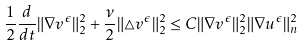Convert formula to latex. <formula><loc_0><loc_0><loc_500><loc_500>\frac { 1 } { 2 } \frac { d } { d t } \| \nabla v ^ { \epsilon } \| ^ { 2 } _ { 2 } + \frac { \nu } { 2 } \| \triangle v ^ { \epsilon } \| ^ { 2 } _ { 2 } \leq C \| \nabla v ^ { \epsilon } \| ^ { 2 } _ { 2 } \| \nabla u ^ { \epsilon } \| ^ { 2 } _ { n }</formula> 